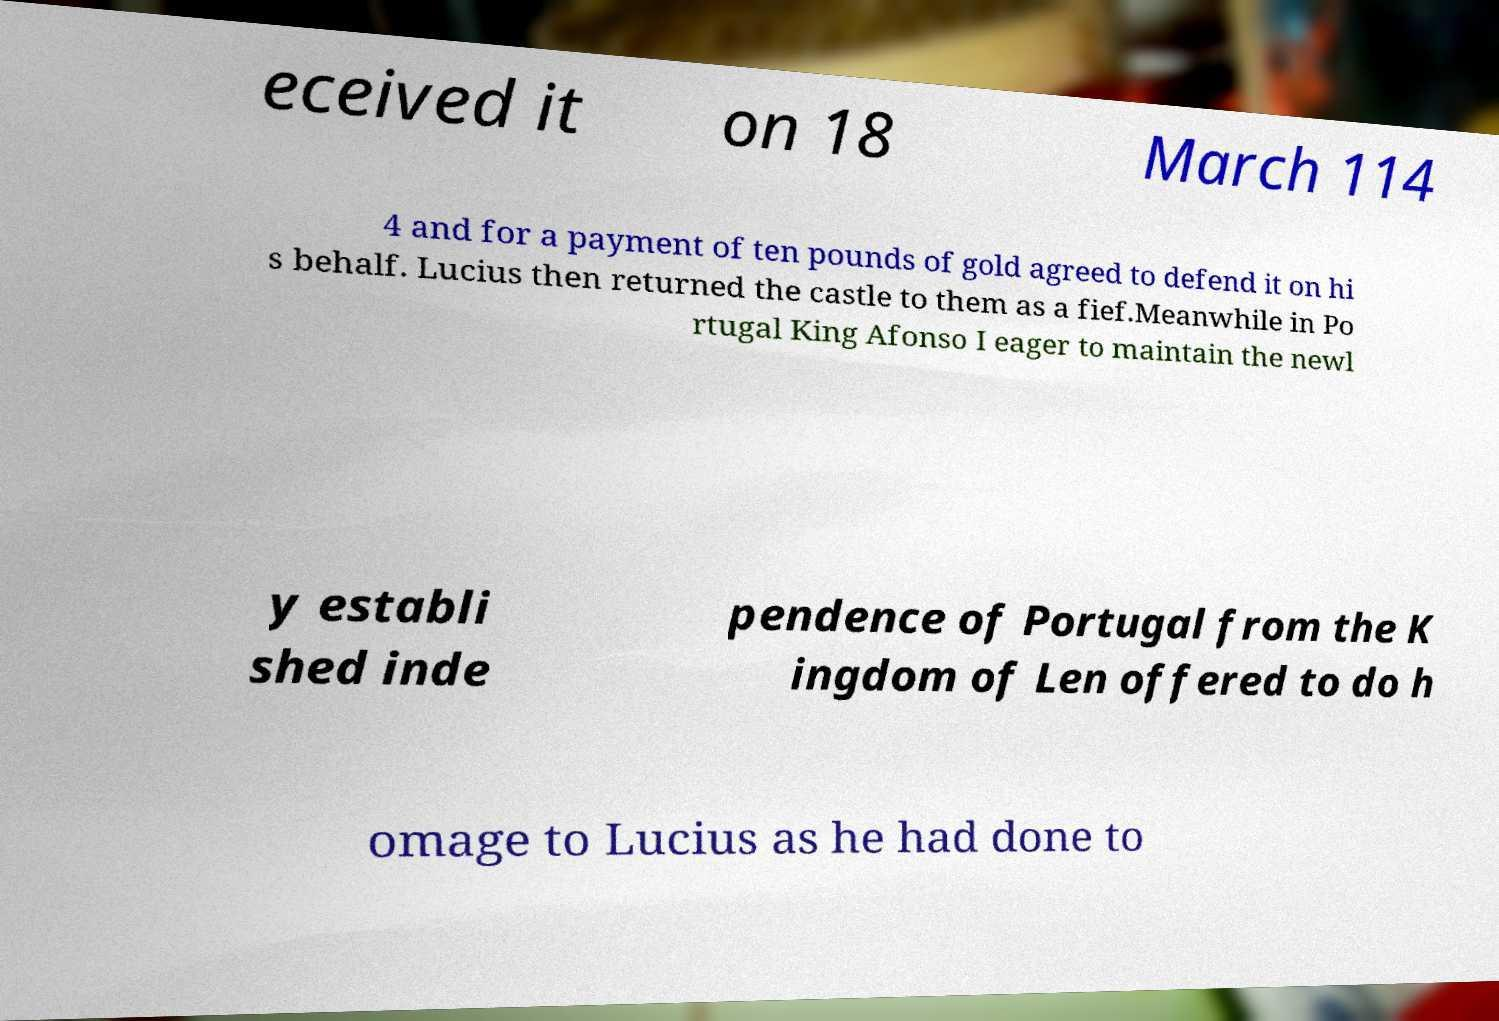Could you assist in decoding the text presented in this image and type it out clearly? eceived it on 18 March 114 4 and for a payment of ten pounds of gold agreed to defend it on hi s behalf. Lucius then returned the castle to them as a fief.Meanwhile in Po rtugal King Afonso I eager to maintain the newl y establi shed inde pendence of Portugal from the K ingdom of Len offered to do h omage to Lucius as he had done to 